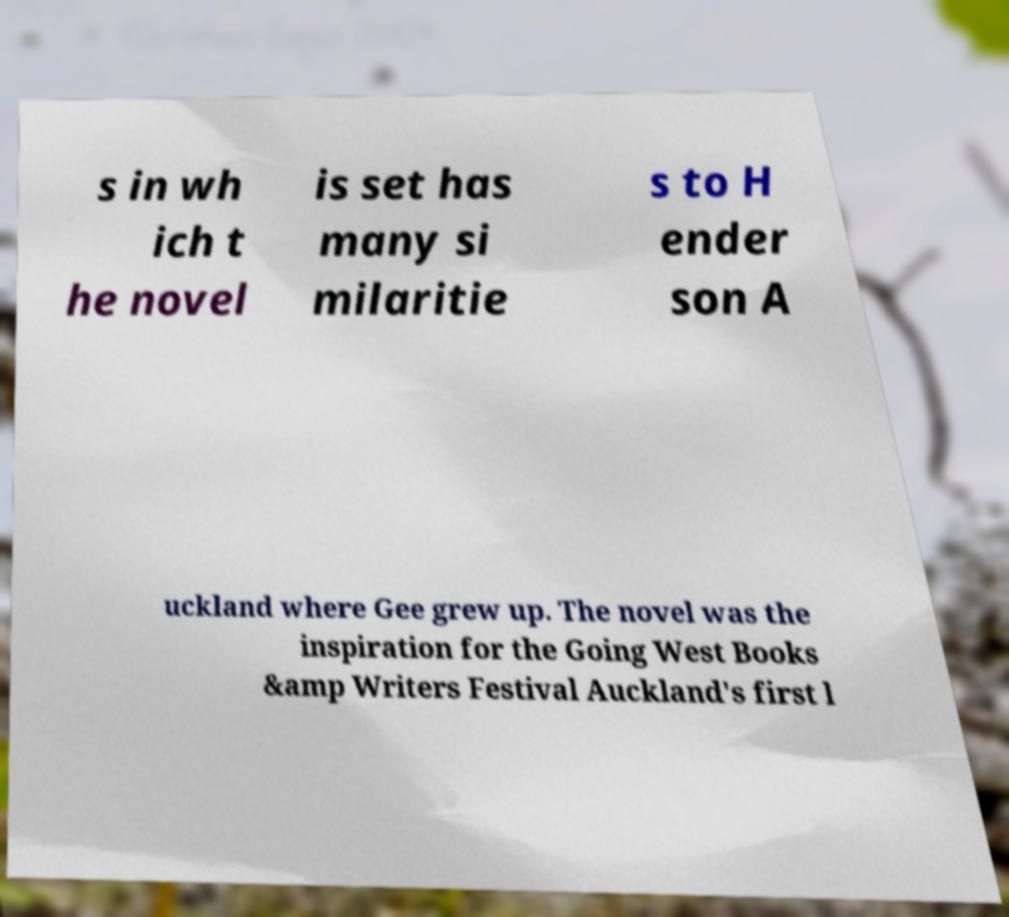For documentation purposes, I need the text within this image transcribed. Could you provide that? s in wh ich t he novel is set has many si milaritie s to H ender son A uckland where Gee grew up. The novel was the inspiration for the Going West Books &amp Writers Festival Auckland's first l 